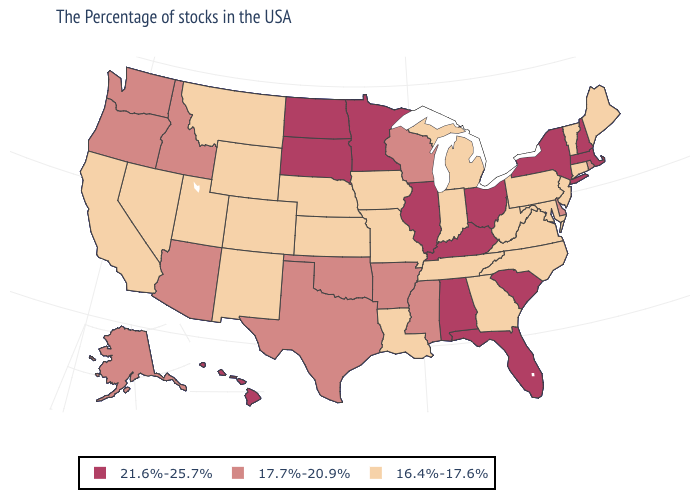What is the value of Iowa?
Give a very brief answer. 16.4%-17.6%. What is the value of North Dakota?
Concise answer only. 21.6%-25.7%. Among the states that border Wyoming , does Idaho have the lowest value?
Write a very short answer. No. Which states have the highest value in the USA?
Short answer required. Massachusetts, New Hampshire, New York, South Carolina, Ohio, Florida, Kentucky, Alabama, Illinois, Minnesota, South Dakota, North Dakota, Hawaii. What is the highest value in states that border California?
Be succinct. 17.7%-20.9%. Name the states that have a value in the range 21.6%-25.7%?
Write a very short answer. Massachusetts, New Hampshire, New York, South Carolina, Ohio, Florida, Kentucky, Alabama, Illinois, Minnesota, South Dakota, North Dakota, Hawaii. Does Colorado have the lowest value in the USA?
Short answer required. Yes. What is the value of Minnesota?
Give a very brief answer. 21.6%-25.7%. What is the lowest value in states that border Illinois?
Quick response, please. 16.4%-17.6%. Does California have the highest value in the USA?
Give a very brief answer. No. What is the value of Mississippi?
Short answer required. 17.7%-20.9%. Name the states that have a value in the range 17.7%-20.9%?
Short answer required. Rhode Island, Delaware, Wisconsin, Mississippi, Arkansas, Oklahoma, Texas, Arizona, Idaho, Washington, Oregon, Alaska. Does Oregon have the lowest value in the West?
Answer briefly. No. What is the value of Florida?
Write a very short answer. 21.6%-25.7%. Is the legend a continuous bar?
Write a very short answer. No. 